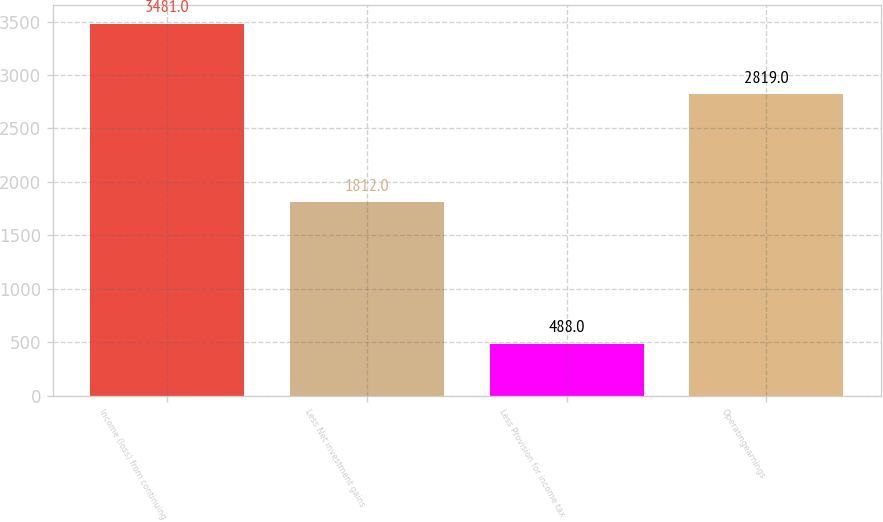Convert chart to OTSL. <chart><loc_0><loc_0><loc_500><loc_500><bar_chart><fcel>Income (loss) from continuing<fcel>Less Net investment gains<fcel>Less Provision for income tax<fcel>Operatingearnings<nl><fcel>3481<fcel>1812<fcel>488<fcel>2819<nl></chart> 